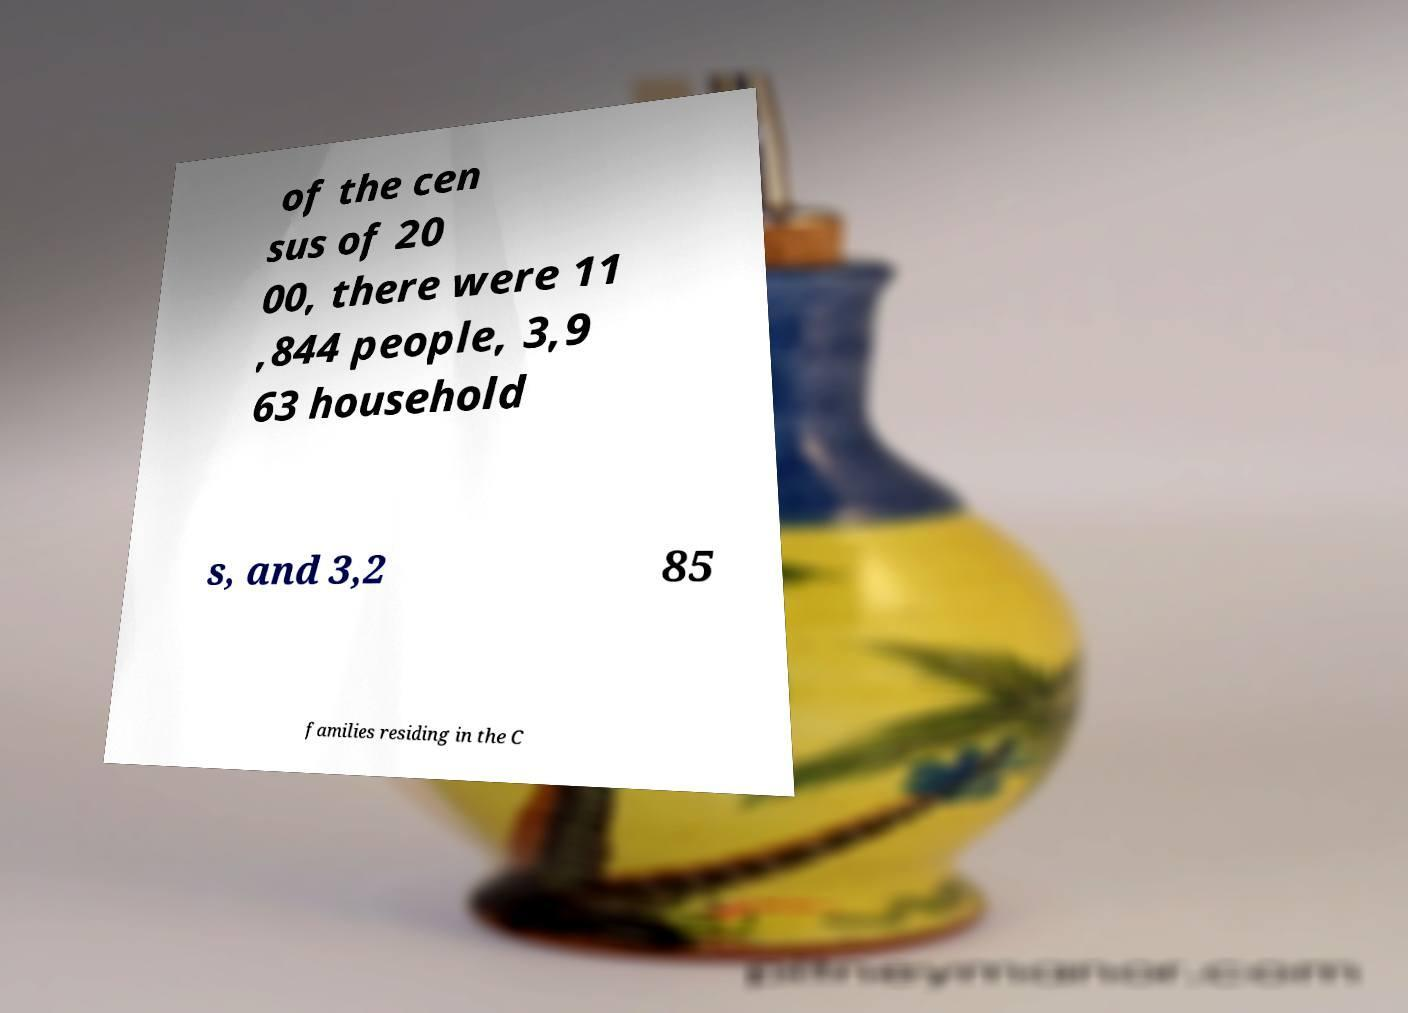Can you accurately transcribe the text from the provided image for me? of the cen sus of 20 00, there were 11 ,844 people, 3,9 63 household s, and 3,2 85 families residing in the C 